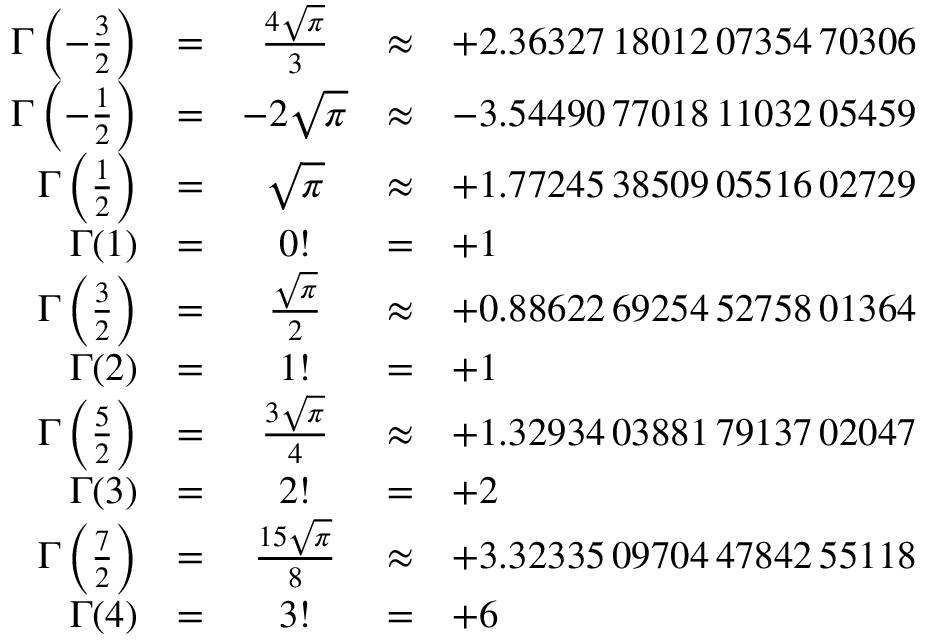<formula> <loc_0><loc_0><loc_500><loc_500>{ \begin{array} { r c c c l } { \Gamma \left ( - { \frac { 3 } { 2 } } \right ) } & { = } & { { \frac { 4 { \sqrt { \pi } } } { 3 } } } & { \approx } & { + 2 . 3 6 3 2 7 \, 1 8 0 1 2 \, 0 7 3 5 4 \, 7 0 3 0 6 } \\ { \Gamma \left ( - { \frac { 1 } { 2 } } \right ) } & { = } & { - 2 { \sqrt { \pi } } } & { \approx } & { - 3 . 5 4 4 9 0 \, 7 7 0 1 8 \, 1 1 0 3 2 \, 0 5 4 5 9 } \\ { \Gamma \left ( { \frac { 1 } { 2 } } \right ) } & { = } & { { \sqrt { \pi } } } & { \approx } & { + 1 . 7 7 2 4 5 \, 3 8 5 0 9 \, 0 5 5 1 6 \, 0 2 7 2 9 } \\ { \Gamma ( 1 ) } & { = } & { 0 ! } & { = } & { + 1 } \\ { \Gamma \left ( { \frac { 3 } { 2 } } \right ) } & { = } & { { \frac { \sqrt { \pi } } { 2 } } } & { \approx } & { + 0 . 8 8 6 2 2 \, 6 9 2 5 4 \, 5 2 7 5 8 \, 0 1 3 6 4 } \\ { \Gamma ( 2 ) } & { = } & { 1 ! } & { = } & { + 1 } \\ { \Gamma \left ( { \frac { 5 } { 2 } } \right ) } & { = } & { { \frac { 3 { \sqrt { \pi } } } { 4 } } } & { \approx } & { + 1 . 3 2 9 3 4 \, 0 3 8 8 1 \, 7 9 1 3 7 \, 0 2 0 4 7 } \\ { \Gamma ( 3 ) } & { = } & { 2 ! } & { = } & { + 2 } \\ { \Gamma \left ( { \frac { 7 } { 2 } } \right ) } & { = } & { { \frac { 1 5 { \sqrt { \pi } } } { 8 } } } & { \approx } & { + 3 . 3 2 3 3 5 \, 0 9 7 0 4 \, 4 7 8 4 2 \, 5 5 1 1 8 } \\ { \Gamma ( 4 ) } & { = } & { 3 ! } & { = } & { + 6 } \end{array} }</formula> 